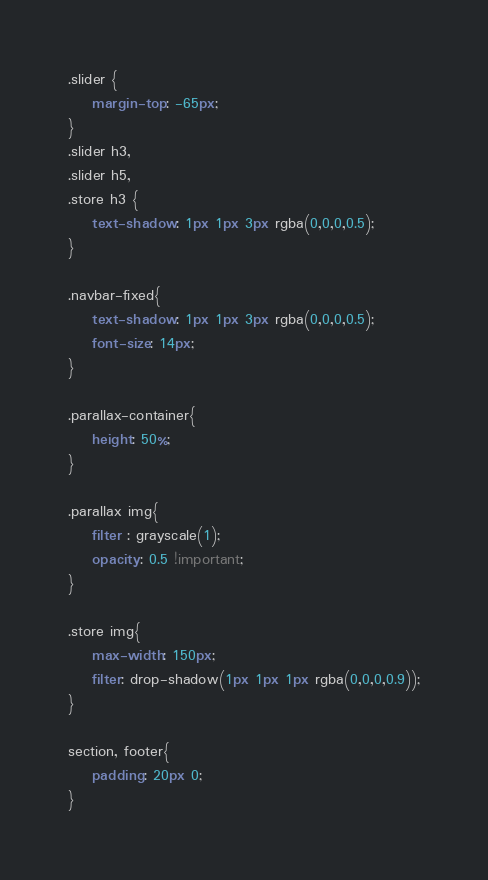Convert code to text. <code><loc_0><loc_0><loc_500><loc_500><_CSS_>.slider {
	margin-top: -65px;
}
.slider h3, 
.slider h5,
.store h3 {
	text-shadow: 1px 1px 3px rgba(0,0,0,0.5);
}

.navbar-fixed{
	text-shadow: 1px 1px 3px rgba(0,0,0,0.5);
	font-size: 14px;
}

.parallax-container{
	height: 50%;
}

.parallax img{
	filter : grayscale(1);
	opacity: 0.5 !important;
}

.store img{
	max-width: 150px;
	filter: drop-shadow(1px 1px 1px rgba(0,0,0,0.9));
}

section, footer{
	padding: 20px 0;
}</code> 